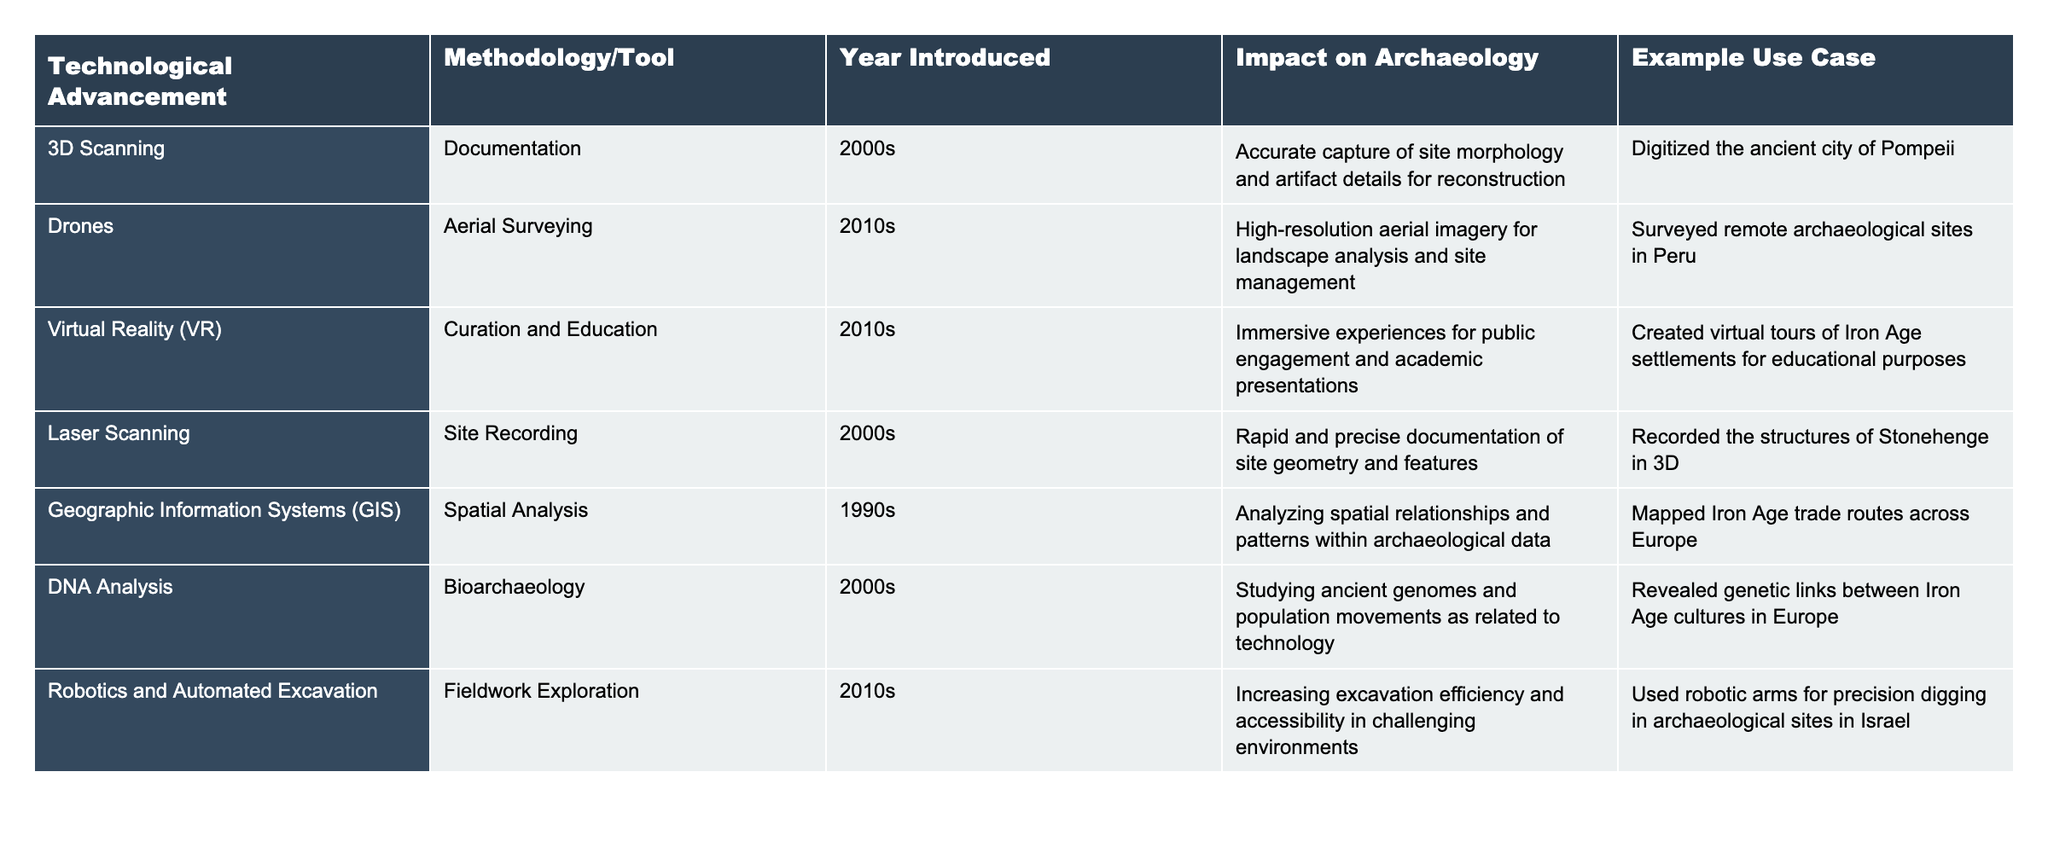What technological advancement was introduced in the 1990s? The table lists "Geographic Information Systems (GIS)" as the only technological advancement introduced in the 1990s.
Answer: Geographic Information Systems (GIS) How many technological advancements are related to bioarchaeology? The table indicates "DNA Analysis" is the only advancement listed under bioarchaeology, so there is one.
Answer: 1 Which methodology/tool was first used for site recording? The table shows that "Laser Scanning" was introduced in the 2000s for site recording, making it the first in this context.
Answer: Laser Scanning What impact do drones have on archaeology? Drones provide high-resolution aerial imagery for landscape analysis and site management, as stated in their impact description.
Answer: High-resolution aerial imagery for landscape analysis Is virtual reality used for excavation purposes according to the table? The table indicates that virtual reality is primarily used for curation and education, not excavation.
Answer: No What are the examples of use cases for 3D scanning and lasers scanning? The table lists "Digitized the ancient city of Pompeii" for 3D scanning and "Recorded the structures of Stonehenge in 3D" for laser scanning.
Answer: Pompeii and Stonehenge What is the difference between the years introduced for drones and robotics and automated excavation? Drones were introduced in the 2010s, while robotics and automated excavation were also introduced in the 2010s, which means there is no difference in their years of introduction.
Answer: 0 years Which technological advancement allows for studying ancient genomes? The table specifies that "DNA Analysis" is the technological advancement that allows for the study of ancient genomes.
Answer: DNA Analysis What is the total number of methodologies/tools listed in the table? There are 7 methodologies/tools listed in the table, counting each entry from the rows provided.
Answer: 7 Which methodology/tool has the most recent introduction year based on the table? The table shows that both drones and robotics and automated excavation were introduced in the 2010s, making them the most recent.
Answer: Drones and Robotics and Automated Excavation What percentage of the advancements focus on documentation and curation compared to total advancements? There are 4 advancements (3D Scanning, Laser Scanning, Virtual Reality, and DNA Analysis) focused on documentation and curation, which is 4 out of 7 advancements, giving approximately 57.14%.
Answer: ~57.14% 